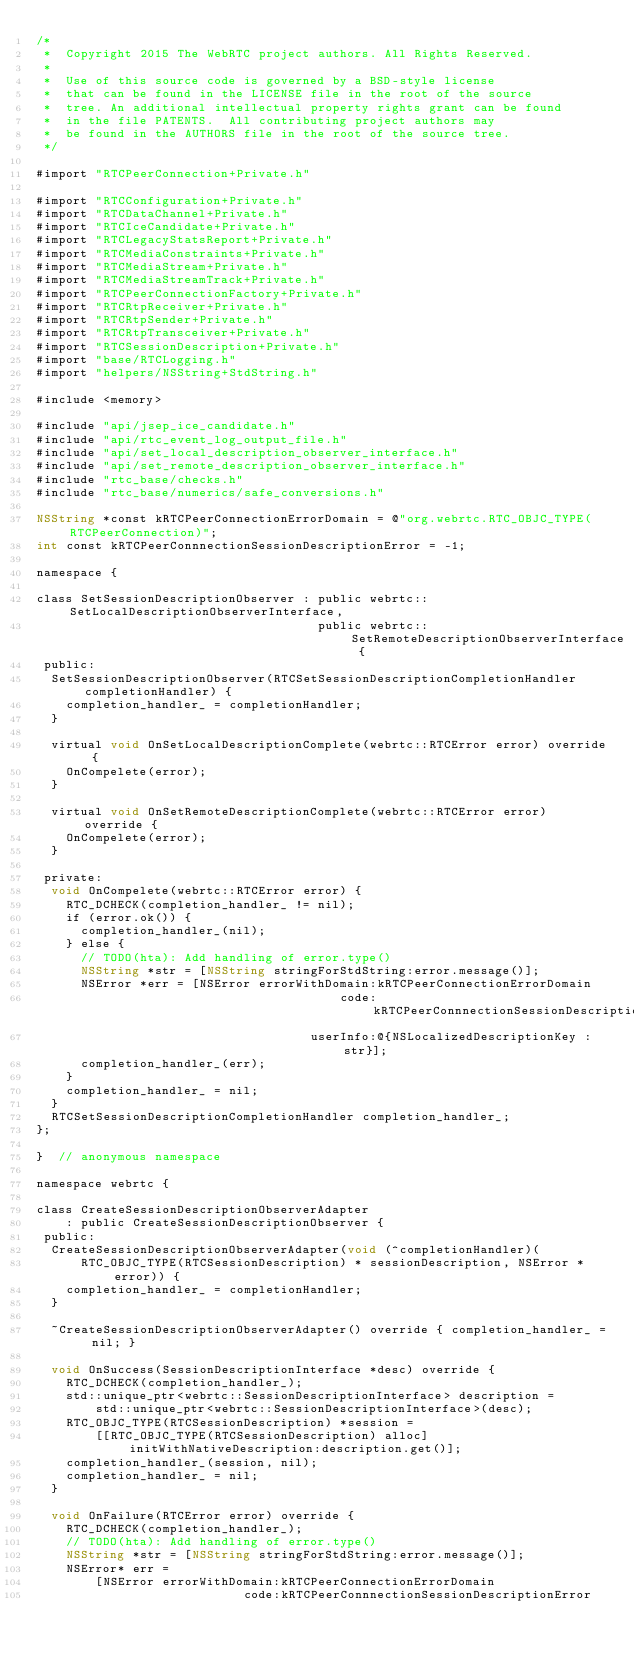Convert code to text. <code><loc_0><loc_0><loc_500><loc_500><_ObjectiveC_>/*
 *  Copyright 2015 The WebRTC project authors. All Rights Reserved.
 *
 *  Use of this source code is governed by a BSD-style license
 *  that can be found in the LICENSE file in the root of the source
 *  tree. An additional intellectual property rights grant can be found
 *  in the file PATENTS.  All contributing project authors may
 *  be found in the AUTHORS file in the root of the source tree.
 */

#import "RTCPeerConnection+Private.h"

#import "RTCConfiguration+Private.h"
#import "RTCDataChannel+Private.h"
#import "RTCIceCandidate+Private.h"
#import "RTCLegacyStatsReport+Private.h"
#import "RTCMediaConstraints+Private.h"
#import "RTCMediaStream+Private.h"
#import "RTCMediaStreamTrack+Private.h"
#import "RTCPeerConnectionFactory+Private.h"
#import "RTCRtpReceiver+Private.h"
#import "RTCRtpSender+Private.h"
#import "RTCRtpTransceiver+Private.h"
#import "RTCSessionDescription+Private.h"
#import "base/RTCLogging.h"
#import "helpers/NSString+StdString.h"

#include <memory>

#include "api/jsep_ice_candidate.h"
#include "api/rtc_event_log_output_file.h"
#include "api/set_local_description_observer_interface.h"
#include "api/set_remote_description_observer_interface.h"
#include "rtc_base/checks.h"
#include "rtc_base/numerics/safe_conversions.h"

NSString *const kRTCPeerConnectionErrorDomain = @"org.webrtc.RTC_OBJC_TYPE(RTCPeerConnection)";
int const kRTCPeerConnnectionSessionDescriptionError = -1;

namespace {

class SetSessionDescriptionObserver : public webrtc::SetLocalDescriptionObserverInterface,
                                      public webrtc::SetRemoteDescriptionObserverInterface {
 public:
  SetSessionDescriptionObserver(RTCSetSessionDescriptionCompletionHandler completionHandler) {
    completion_handler_ = completionHandler;
  }

  virtual void OnSetLocalDescriptionComplete(webrtc::RTCError error) override {
    OnCompelete(error);
  }

  virtual void OnSetRemoteDescriptionComplete(webrtc::RTCError error) override {
    OnCompelete(error);
  }

 private:
  void OnCompelete(webrtc::RTCError error) {
    RTC_DCHECK(completion_handler_ != nil);
    if (error.ok()) {
      completion_handler_(nil);
    } else {
      // TODO(hta): Add handling of error.type()
      NSString *str = [NSString stringForStdString:error.message()];
      NSError *err = [NSError errorWithDomain:kRTCPeerConnectionErrorDomain
                                         code:kRTCPeerConnnectionSessionDescriptionError
                                     userInfo:@{NSLocalizedDescriptionKey : str}];
      completion_handler_(err);
    }
    completion_handler_ = nil;
  }
  RTCSetSessionDescriptionCompletionHandler completion_handler_;
};

}  // anonymous namespace

namespace webrtc {

class CreateSessionDescriptionObserverAdapter
    : public CreateSessionDescriptionObserver {
 public:
  CreateSessionDescriptionObserverAdapter(void (^completionHandler)(
      RTC_OBJC_TYPE(RTCSessionDescription) * sessionDescription, NSError *error)) {
    completion_handler_ = completionHandler;
  }

  ~CreateSessionDescriptionObserverAdapter() override { completion_handler_ = nil; }

  void OnSuccess(SessionDescriptionInterface *desc) override {
    RTC_DCHECK(completion_handler_);
    std::unique_ptr<webrtc::SessionDescriptionInterface> description =
        std::unique_ptr<webrtc::SessionDescriptionInterface>(desc);
    RTC_OBJC_TYPE(RTCSessionDescription) *session =
        [[RTC_OBJC_TYPE(RTCSessionDescription) alloc] initWithNativeDescription:description.get()];
    completion_handler_(session, nil);
    completion_handler_ = nil;
  }

  void OnFailure(RTCError error) override {
    RTC_DCHECK(completion_handler_);
    // TODO(hta): Add handling of error.type()
    NSString *str = [NSString stringForStdString:error.message()];
    NSError* err =
        [NSError errorWithDomain:kRTCPeerConnectionErrorDomain
                            code:kRTCPeerConnnectionSessionDescriptionError</code> 